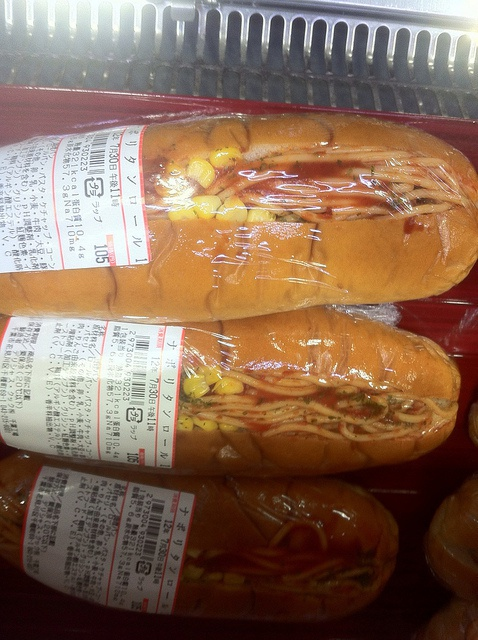Describe the objects in this image and their specific colors. I can see sandwich in lightgray, tan, white, red, and salmon tones, sandwich in lightgray, brown, maroon, and darkgray tones, sandwich in lightgray, black, maroon, and gray tones, and hot dog in black, maroon, and lightgray tones in this image. 